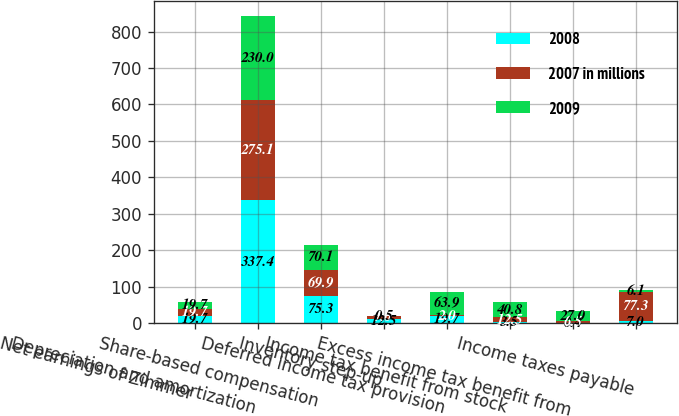<chart> <loc_0><loc_0><loc_500><loc_500><stacked_bar_chart><ecel><fcel>Net earnings of Zimmer<fcel>Depreciation and amortization<fcel>Share-based compensation<fcel>Inventory step-up<fcel>Deferred income tax provision<fcel>Income tax benefit from stock<fcel>Excess income tax benefit from<fcel>Income taxes payable<nl><fcel>2008<fcel>19.7<fcel>337.4<fcel>75.3<fcel>12.5<fcel>19.7<fcel>3.5<fcel>0.4<fcel>7<nl><fcel>2007 in millions<fcel>19.7<fcel>275.1<fcel>69.9<fcel>7<fcel>2<fcel>12.5<fcel>6.5<fcel>77.3<nl><fcel>2009<fcel>19.7<fcel>230<fcel>70.1<fcel>0.5<fcel>63.9<fcel>40.8<fcel>27<fcel>6.1<nl></chart> 